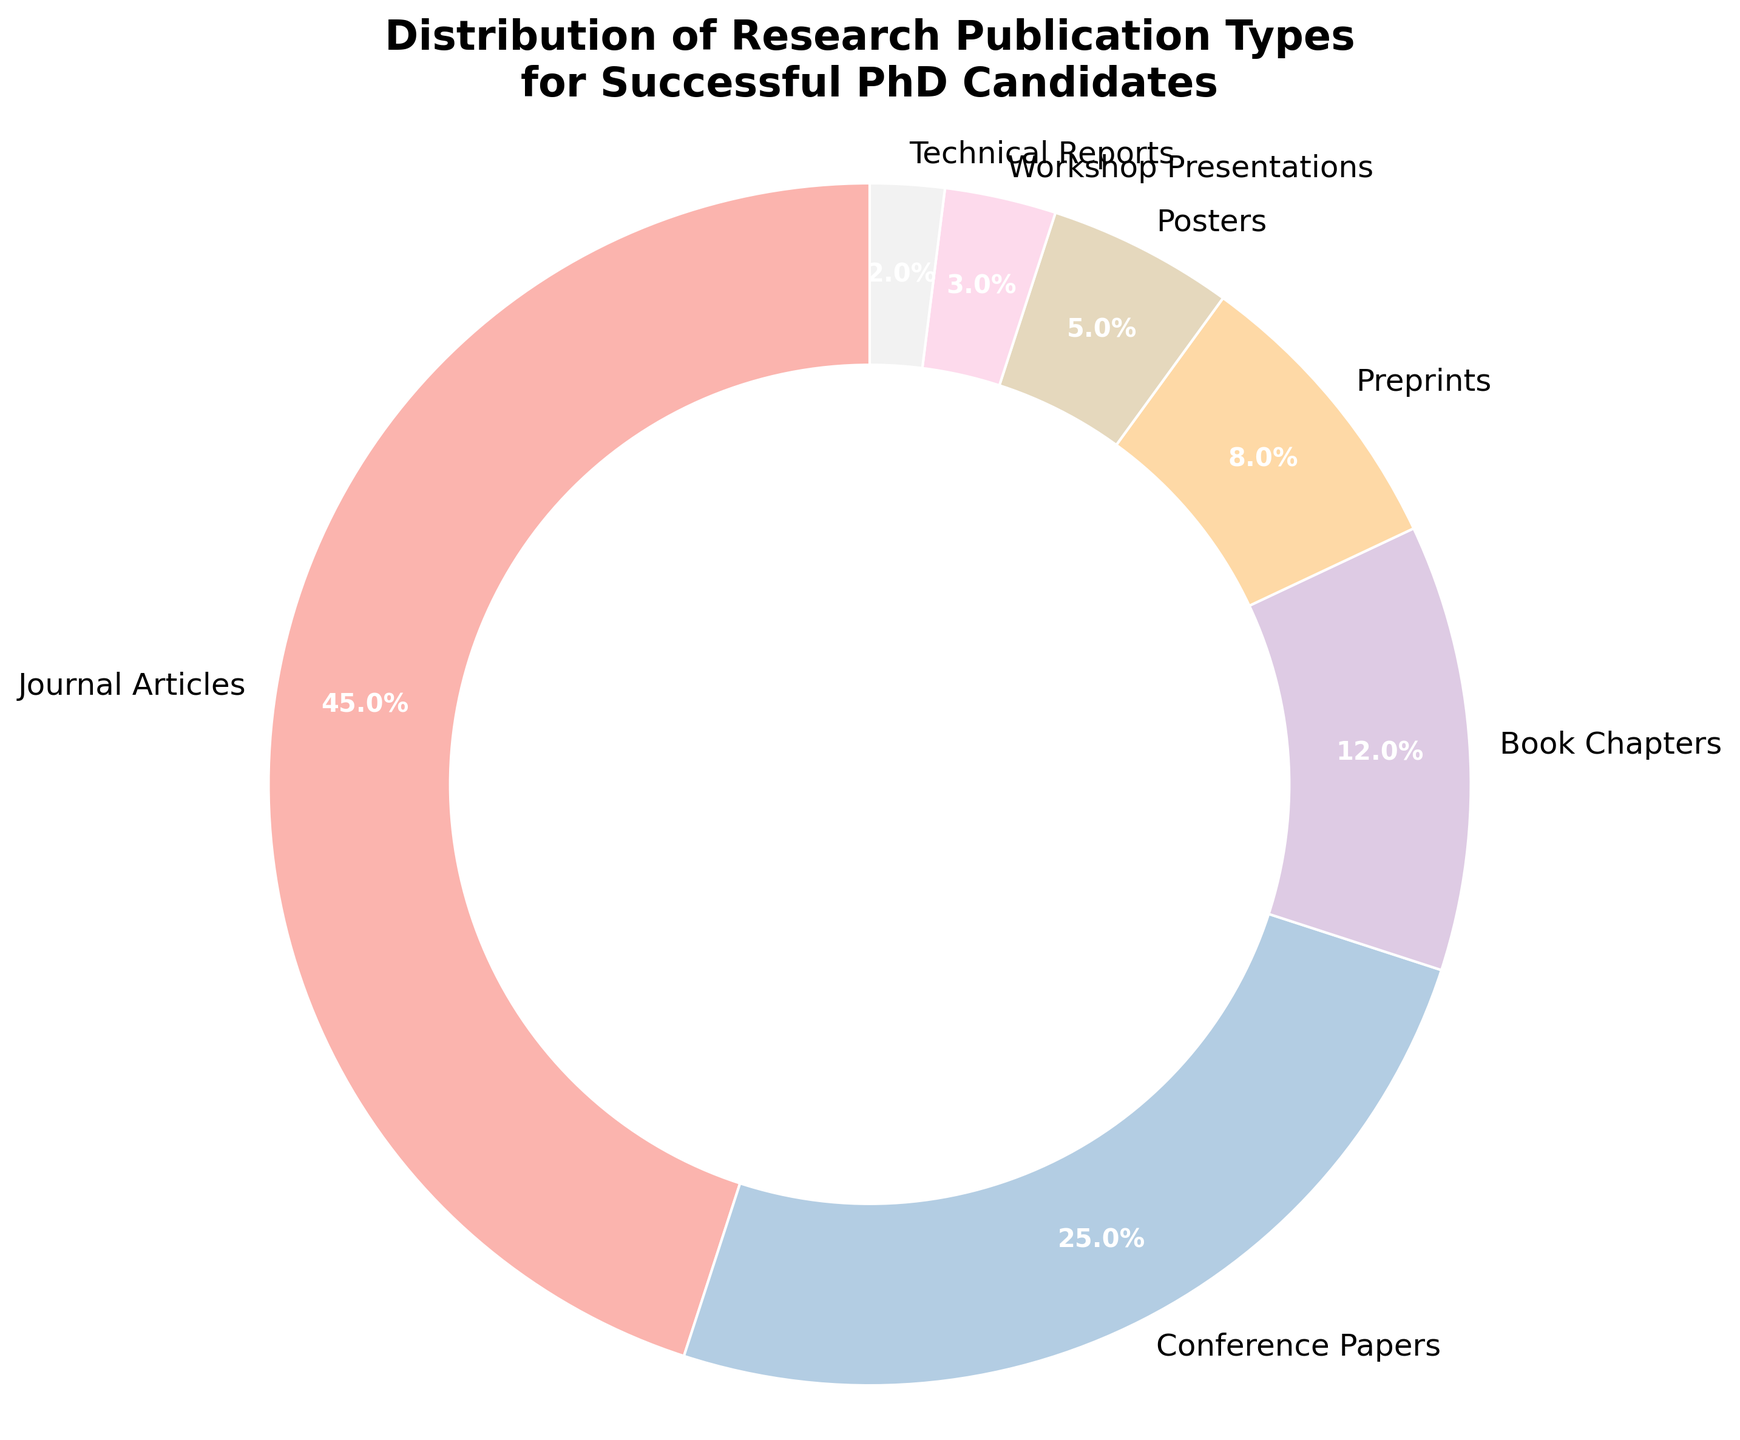Which publication type has the highest percentage? Look at the sections of the pie chart and identify the one with the largest slice. The label that corresponds to this slice indicates the publication type with the highest percentage.
Answer: Journal Articles What is the combined percentage of Preprints and Posters? Sum the percentages labeled as Preprints (8%) and Posters (5%). The result is the combined percentage of these two publication types.
Answer: 13% How much more common are Journal Articles compared to Technical Reports? Subtract the percentage of Technical Reports (2%) from the percentage of Journal Articles (45%). This gives the difference in their commonality.
Answer: 43% Which two publication types have a combined percentage closest to that of Journal Articles? Compare the percentages and find two types whose total (e.g., Conference Papers 25% + Book Chapters 12% = 37%) is closest to 45%, the percentage of Journal Articles.
Answer: Conference Papers and Book Chapters What percentage of publications are not Journal Articles or Conference Papers? Add the percentages of all publication types other than Journal Articles and Conference Papers: (12 + 8 + 5 + 3 + 2).
Answer: 30% Which publication type occupies the smallest percentage of the pie chart? Identify the slice with the smallest label. The corresponding publication type is the one that occupies the smallest percentage.
Answer: Technical Reports By how much does the percentage of Conference Papers exceed that of Book Chapters? Subtract the percentage of Book Chapters (12%) from the percentage of Conference Papers (25%) to find the excess percentage.
Answer: 13% What is the percentage difference between Preprints and Workshop Presentations? Subtract the percentage of Workshop Presentations (3%) from Preprints (8%) to calculate the difference.
Answer: 5% What is the visual distinguishing feature of the pie chart? Visually identify the most standout feature, such as the separated wedges or the central white circle.
Answer: Central white circle Are any publication types equal in percentage? Check each percentage value and verify if any two types share the same number.
Answer: No 